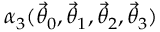Convert formula to latex. <formula><loc_0><loc_0><loc_500><loc_500>\alpha _ { 3 } ( { \vec { \theta } } _ { 0 } , { \vec { \theta } } _ { 1 } , { \vec { \theta } } _ { 2 } , { \vec { \theta } } _ { 3 } )</formula> 